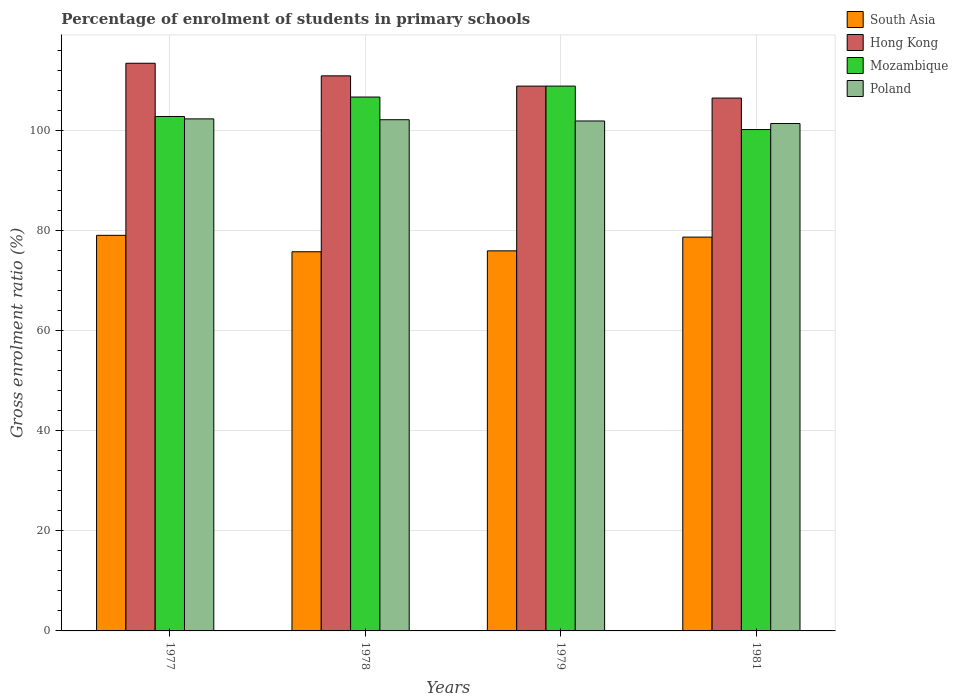Are the number of bars per tick equal to the number of legend labels?
Your answer should be very brief. Yes. How many bars are there on the 2nd tick from the left?
Keep it short and to the point. 4. How many bars are there on the 3rd tick from the right?
Provide a short and direct response. 4. What is the label of the 1st group of bars from the left?
Your answer should be very brief. 1977. What is the percentage of students enrolled in primary schools in Poland in 1979?
Your response must be concise. 101.88. Across all years, what is the maximum percentage of students enrolled in primary schools in Poland?
Keep it short and to the point. 102.3. Across all years, what is the minimum percentage of students enrolled in primary schools in South Asia?
Provide a short and direct response. 75.75. What is the total percentage of students enrolled in primary schools in Mozambique in the graph?
Ensure brevity in your answer.  418.45. What is the difference between the percentage of students enrolled in primary schools in South Asia in 1977 and that in 1979?
Provide a short and direct response. 3.1. What is the difference between the percentage of students enrolled in primary schools in Hong Kong in 1981 and the percentage of students enrolled in primary schools in Mozambique in 1978?
Keep it short and to the point. -0.21. What is the average percentage of students enrolled in primary schools in Mozambique per year?
Offer a terse response. 104.61. In the year 1979, what is the difference between the percentage of students enrolled in primary schools in Mozambique and percentage of students enrolled in primary schools in South Asia?
Your answer should be compact. 32.92. What is the ratio of the percentage of students enrolled in primary schools in Mozambique in 1978 to that in 1979?
Offer a very short reply. 0.98. Is the percentage of students enrolled in primary schools in Hong Kong in 1977 less than that in 1978?
Ensure brevity in your answer.  No. Is the difference between the percentage of students enrolled in primary schools in Mozambique in 1977 and 1981 greater than the difference between the percentage of students enrolled in primary schools in South Asia in 1977 and 1981?
Offer a terse response. Yes. What is the difference between the highest and the second highest percentage of students enrolled in primary schools in Mozambique?
Your answer should be compact. 2.19. What is the difference between the highest and the lowest percentage of students enrolled in primary schools in Poland?
Offer a very short reply. 0.93. In how many years, is the percentage of students enrolled in primary schools in Mozambique greater than the average percentage of students enrolled in primary schools in Mozambique taken over all years?
Your answer should be compact. 2. Is it the case that in every year, the sum of the percentage of students enrolled in primary schools in South Asia and percentage of students enrolled in primary schools in Mozambique is greater than the sum of percentage of students enrolled in primary schools in Hong Kong and percentage of students enrolled in primary schools in Poland?
Keep it short and to the point. Yes. What does the 1st bar from the left in 1977 represents?
Offer a terse response. South Asia. What does the 2nd bar from the right in 1977 represents?
Ensure brevity in your answer.  Mozambique. Is it the case that in every year, the sum of the percentage of students enrolled in primary schools in Hong Kong and percentage of students enrolled in primary schools in Mozambique is greater than the percentage of students enrolled in primary schools in Poland?
Make the answer very short. Yes. How many bars are there?
Keep it short and to the point. 16. How many years are there in the graph?
Provide a succinct answer. 4. Are the values on the major ticks of Y-axis written in scientific E-notation?
Keep it short and to the point. No. Where does the legend appear in the graph?
Your answer should be very brief. Top right. How many legend labels are there?
Offer a terse response. 4. How are the legend labels stacked?
Provide a succinct answer. Vertical. What is the title of the graph?
Give a very brief answer. Percentage of enrolment of students in primary schools. What is the label or title of the X-axis?
Keep it short and to the point. Years. What is the label or title of the Y-axis?
Your answer should be compact. Gross enrolment ratio (%). What is the Gross enrolment ratio (%) of South Asia in 1977?
Your response must be concise. 79.03. What is the Gross enrolment ratio (%) in Hong Kong in 1977?
Your answer should be very brief. 113.41. What is the Gross enrolment ratio (%) in Mozambique in 1977?
Your response must be concise. 102.78. What is the Gross enrolment ratio (%) of Poland in 1977?
Your response must be concise. 102.3. What is the Gross enrolment ratio (%) of South Asia in 1978?
Give a very brief answer. 75.75. What is the Gross enrolment ratio (%) of Hong Kong in 1978?
Your answer should be very brief. 110.89. What is the Gross enrolment ratio (%) in Mozambique in 1978?
Your response must be concise. 106.66. What is the Gross enrolment ratio (%) in Poland in 1978?
Provide a succinct answer. 102.13. What is the Gross enrolment ratio (%) of South Asia in 1979?
Offer a terse response. 75.93. What is the Gross enrolment ratio (%) in Hong Kong in 1979?
Your answer should be compact. 108.84. What is the Gross enrolment ratio (%) of Mozambique in 1979?
Make the answer very short. 108.85. What is the Gross enrolment ratio (%) in Poland in 1979?
Make the answer very short. 101.88. What is the Gross enrolment ratio (%) of South Asia in 1981?
Offer a terse response. 78.68. What is the Gross enrolment ratio (%) of Hong Kong in 1981?
Offer a terse response. 106.45. What is the Gross enrolment ratio (%) in Mozambique in 1981?
Offer a very short reply. 100.16. What is the Gross enrolment ratio (%) of Poland in 1981?
Provide a succinct answer. 101.37. Across all years, what is the maximum Gross enrolment ratio (%) of South Asia?
Give a very brief answer. 79.03. Across all years, what is the maximum Gross enrolment ratio (%) of Hong Kong?
Give a very brief answer. 113.41. Across all years, what is the maximum Gross enrolment ratio (%) of Mozambique?
Give a very brief answer. 108.85. Across all years, what is the maximum Gross enrolment ratio (%) in Poland?
Provide a short and direct response. 102.3. Across all years, what is the minimum Gross enrolment ratio (%) of South Asia?
Ensure brevity in your answer.  75.75. Across all years, what is the minimum Gross enrolment ratio (%) of Hong Kong?
Provide a succinct answer. 106.45. Across all years, what is the minimum Gross enrolment ratio (%) in Mozambique?
Make the answer very short. 100.16. Across all years, what is the minimum Gross enrolment ratio (%) of Poland?
Offer a very short reply. 101.37. What is the total Gross enrolment ratio (%) in South Asia in the graph?
Your answer should be compact. 309.39. What is the total Gross enrolment ratio (%) in Hong Kong in the graph?
Give a very brief answer. 439.6. What is the total Gross enrolment ratio (%) of Mozambique in the graph?
Your answer should be very brief. 418.45. What is the total Gross enrolment ratio (%) of Poland in the graph?
Keep it short and to the point. 407.67. What is the difference between the Gross enrolment ratio (%) of South Asia in 1977 and that in 1978?
Make the answer very short. 3.28. What is the difference between the Gross enrolment ratio (%) in Hong Kong in 1977 and that in 1978?
Ensure brevity in your answer.  2.52. What is the difference between the Gross enrolment ratio (%) in Mozambique in 1977 and that in 1978?
Your answer should be very brief. -3.89. What is the difference between the Gross enrolment ratio (%) of Poland in 1977 and that in 1978?
Your answer should be very brief. 0.17. What is the difference between the Gross enrolment ratio (%) of South Asia in 1977 and that in 1979?
Provide a succinct answer. 3.1. What is the difference between the Gross enrolment ratio (%) in Hong Kong in 1977 and that in 1979?
Offer a terse response. 4.57. What is the difference between the Gross enrolment ratio (%) in Mozambique in 1977 and that in 1979?
Give a very brief answer. -6.07. What is the difference between the Gross enrolment ratio (%) in Poland in 1977 and that in 1979?
Your response must be concise. 0.42. What is the difference between the Gross enrolment ratio (%) of South Asia in 1977 and that in 1981?
Give a very brief answer. 0.36. What is the difference between the Gross enrolment ratio (%) of Hong Kong in 1977 and that in 1981?
Provide a succinct answer. 6.96. What is the difference between the Gross enrolment ratio (%) in Mozambique in 1977 and that in 1981?
Ensure brevity in your answer.  2.61. What is the difference between the Gross enrolment ratio (%) of Poland in 1977 and that in 1981?
Offer a very short reply. 0.93. What is the difference between the Gross enrolment ratio (%) of South Asia in 1978 and that in 1979?
Your response must be concise. -0.18. What is the difference between the Gross enrolment ratio (%) in Hong Kong in 1978 and that in 1979?
Your answer should be compact. 2.05. What is the difference between the Gross enrolment ratio (%) of Mozambique in 1978 and that in 1979?
Give a very brief answer. -2.19. What is the difference between the Gross enrolment ratio (%) in Poland in 1978 and that in 1979?
Your answer should be compact. 0.25. What is the difference between the Gross enrolment ratio (%) in South Asia in 1978 and that in 1981?
Your answer should be compact. -2.93. What is the difference between the Gross enrolment ratio (%) of Hong Kong in 1978 and that in 1981?
Your response must be concise. 4.44. What is the difference between the Gross enrolment ratio (%) in Mozambique in 1978 and that in 1981?
Your answer should be compact. 6.5. What is the difference between the Gross enrolment ratio (%) of Poland in 1978 and that in 1981?
Offer a terse response. 0.76. What is the difference between the Gross enrolment ratio (%) in South Asia in 1979 and that in 1981?
Offer a terse response. -2.75. What is the difference between the Gross enrolment ratio (%) of Hong Kong in 1979 and that in 1981?
Your answer should be very brief. 2.39. What is the difference between the Gross enrolment ratio (%) of Mozambique in 1979 and that in 1981?
Provide a short and direct response. 8.68. What is the difference between the Gross enrolment ratio (%) in Poland in 1979 and that in 1981?
Provide a succinct answer. 0.51. What is the difference between the Gross enrolment ratio (%) of South Asia in 1977 and the Gross enrolment ratio (%) of Hong Kong in 1978?
Ensure brevity in your answer.  -31.86. What is the difference between the Gross enrolment ratio (%) in South Asia in 1977 and the Gross enrolment ratio (%) in Mozambique in 1978?
Provide a short and direct response. -27.63. What is the difference between the Gross enrolment ratio (%) of South Asia in 1977 and the Gross enrolment ratio (%) of Poland in 1978?
Your response must be concise. -23.09. What is the difference between the Gross enrolment ratio (%) of Hong Kong in 1977 and the Gross enrolment ratio (%) of Mozambique in 1978?
Your answer should be very brief. 6.75. What is the difference between the Gross enrolment ratio (%) in Hong Kong in 1977 and the Gross enrolment ratio (%) in Poland in 1978?
Offer a very short reply. 11.28. What is the difference between the Gross enrolment ratio (%) of Mozambique in 1977 and the Gross enrolment ratio (%) of Poland in 1978?
Your answer should be compact. 0.65. What is the difference between the Gross enrolment ratio (%) of South Asia in 1977 and the Gross enrolment ratio (%) of Hong Kong in 1979?
Give a very brief answer. -29.81. What is the difference between the Gross enrolment ratio (%) of South Asia in 1977 and the Gross enrolment ratio (%) of Mozambique in 1979?
Your answer should be very brief. -29.82. What is the difference between the Gross enrolment ratio (%) in South Asia in 1977 and the Gross enrolment ratio (%) in Poland in 1979?
Provide a succinct answer. -22.85. What is the difference between the Gross enrolment ratio (%) of Hong Kong in 1977 and the Gross enrolment ratio (%) of Mozambique in 1979?
Your response must be concise. 4.56. What is the difference between the Gross enrolment ratio (%) in Hong Kong in 1977 and the Gross enrolment ratio (%) in Poland in 1979?
Give a very brief answer. 11.53. What is the difference between the Gross enrolment ratio (%) in Mozambique in 1977 and the Gross enrolment ratio (%) in Poland in 1979?
Your answer should be very brief. 0.9. What is the difference between the Gross enrolment ratio (%) of South Asia in 1977 and the Gross enrolment ratio (%) of Hong Kong in 1981?
Keep it short and to the point. -27.42. What is the difference between the Gross enrolment ratio (%) in South Asia in 1977 and the Gross enrolment ratio (%) in Mozambique in 1981?
Give a very brief answer. -21.13. What is the difference between the Gross enrolment ratio (%) in South Asia in 1977 and the Gross enrolment ratio (%) in Poland in 1981?
Give a very brief answer. -22.34. What is the difference between the Gross enrolment ratio (%) in Hong Kong in 1977 and the Gross enrolment ratio (%) in Mozambique in 1981?
Ensure brevity in your answer.  13.24. What is the difference between the Gross enrolment ratio (%) in Hong Kong in 1977 and the Gross enrolment ratio (%) in Poland in 1981?
Your answer should be compact. 12.04. What is the difference between the Gross enrolment ratio (%) in Mozambique in 1977 and the Gross enrolment ratio (%) in Poland in 1981?
Give a very brief answer. 1.41. What is the difference between the Gross enrolment ratio (%) of South Asia in 1978 and the Gross enrolment ratio (%) of Hong Kong in 1979?
Ensure brevity in your answer.  -33.09. What is the difference between the Gross enrolment ratio (%) in South Asia in 1978 and the Gross enrolment ratio (%) in Mozambique in 1979?
Offer a very short reply. -33.1. What is the difference between the Gross enrolment ratio (%) in South Asia in 1978 and the Gross enrolment ratio (%) in Poland in 1979?
Offer a terse response. -26.13. What is the difference between the Gross enrolment ratio (%) of Hong Kong in 1978 and the Gross enrolment ratio (%) of Mozambique in 1979?
Your answer should be very brief. 2.04. What is the difference between the Gross enrolment ratio (%) in Hong Kong in 1978 and the Gross enrolment ratio (%) in Poland in 1979?
Provide a short and direct response. 9.01. What is the difference between the Gross enrolment ratio (%) in Mozambique in 1978 and the Gross enrolment ratio (%) in Poland in 1979?
Your answer should be very brief. 4.78. What is the difference between the Gross enrolment ratio (%) of South Asia in 1978 and the Gross enrolment ratio (%) of Hong Kong in 1981?
Ensure brevity in your answer.  -30.7. What is the difference between the Gross enrolment ratio (%) in South Asia in 1978 and the Gross enrolment ratio (%) in Mozambique in 1981?
Provide a succinct answer. -24.42. What is the difference between the Gross enrolment ratio (%) in South Asia in 1978 and the Gross enrolment ratio (%) in Poland in 1981?
Ensure brevity in your answer.  -25.62. What is the difference between the Gross enrolment ratio (%) of Hong Kong in 1978 and the Gross enrolment ratio (%) of Mozambique in 1981?
Offer a very short reply. 10.73. What is the difference between the Gross enrolment ratio (%) in Hong Kong in 1978 and the Gross enrolment ratio (%) in Poland in 1981?
Offer a terse response. 9.52. What is the difference between the Gross enrolment ratio (%) of Mozambique in 1978 and the Gross enrolment ratio (%) of Poland in 1981?
Your answer should be very brief. 5.29. What is the difference between the Gross enrolment ratio (%) of South Asia in 1979 and the Gross enrolment ratio (%) of Hong Kong in 1981?
Offer a terse response. -30.52. What is the difference between the Gross enrolment ratio (%) in South Asia in 1979 and the Gross enrolment ratio (%) in Mozambique in 1981?
Keep it short and to the point. -24.24. What is the difference between the Gross enrolment ratio (%) in South Asia in 1979 and the Gross enrolment ratio (%) in Poland in 1981?
Provide a succinct answer. -25.44. What is the difference between the Gross enrolment ratio (%) in Hong Kong in 1979 and the Gross enrolment ratio (%) in Mozambique in 1981?
Give a very brief answer. 8.68. What is the difference between the Gross enrolment ratio (%) in Hong Kong in 1979 and the Gross enrolment ratio (%) in Poland in 1981?
Offer a very short reply. 7.47. What is the difference between the Gross enrolment ratio (%) of Mozambique in 1979 and the Gross enrolment ratio (%) of Poland in 1981?
Provide a succinct answer. 7.48. What is the average Gross enrolment ratio (%) of South Asia per year?
Make the answer very short. 77.35. What is the average Gross enrolment ratio (%) in Hong Kong per year?
Make the answer very short. 109.9. What is the average Gross enrolment ratio (%) in Mozambique per year?
Make the answer very short. 104.61. What is the average Gross enrolment ratio (%) in Poland per year?
Make the answer very short. 101.92. In the year 1977, what is the difference between the Gross enrolment ratio (%) of South Asia and Gross enrolment ratio (%) of Hong Kong?
Keep it short and to the point. -34.38. In the year 1977, what is the difference between the Gross enrolment ratio (%) in South Asia and Gross enrolment ratio (%) in Mozambique?
Ensure brevity in your answer.  -23.74. In the year 1977, what is the difference between the Gross enrolment ratio (%) in South Asia and Gross enrolment ratio (%) in Poland?
Your answer should be compact. -23.26. In the year 1977, what is the difference between the Gross enrolment ratio (%) in Hong Kong and Gross enrolment ratio (%) in Mozambique?
Your answer should be compact. 10.63. In the year 1977, what is the difference between the Gross enrolment ratio (%) of Hong Kong and Gross enrolment ratio (%) of Poland?
Make the answer very short. 11.11. In the year 1977, what is the difference between the Gross enrolment ratio (%) in Mozambique and Gross enrolment ratio (%) in Poland?
Your answer should be very brief. 0.48. In the year 1978, what is the difference between the Gross enrolment ratio (%) of South Asia and Gross enrolment ratio (%) of Hong Kong?
Ensure brevity in your answer.  -35.14. In the year 1978, what is the difference between the Gross enrolment ratio (%) of South Asia and Gross enrolment ratio (%) of Mozambique?
Your answer should be compact. -30.91. In the year 1978, what is the difference between the Gross enrolment ratio (%) in South Asia and Gross enrolment ratio (%) in Poland?
Your answer should be compact. -26.38. In the year 1978, what is the difference between the Gross enrolment ratio (%) of Hong Kong and Gross enrolment ratio (%) of Mozambique?
Your answer should be very brief. 4.23. In the year 1978, what is the difference between the Gross enrolment ratio (%) in Hong Kong and Gross enrolment ratio (%) in Poland?
Make the answer very short. 8.76. In the year 1978, what is the difference between the Gross enrolment ratio (%) in Mozambique and Gross enrolment ratio (%) in Poland?
Give a very brief answer. 4.53. In the year 1979, what is the difference between the Gross enrolment ratio (%) of South Asia and Gross enrolment ratio (%) of Hong Kong?
Your response must be concise. -32.91. In the year 1979, what is the difference between the Gross enrolment ratio (%) of South Asia and Gross enrolment ratio (%) of Mozambique?
Give a very brief answer. -32.92. In the year 1979, what is the difference between the Gross enrolment ratio (%) of South Asia and Gross enrolment ratio (%) of Poland?
Ensure brevity in your answer.  -25.95. In the year 1979, what is the difference between the Gross enrolment ratio (%) of Hong Kong and Gross enrolment ratio (%) of Mozambique?
Provide a short and direct response. -0. In the year 1979, what is the difference between the Gross enrolment ratio (%) in Hong Kong and Gross enrolment ratio (%) in Poland?
Keep it short and to the point. 6.97. In the year 1979, what is the difference between the Gross enrolment ratio (%) of Mozambique and Gross enrolment ratio (%) of Poland?
Your answer should be very brief. 6.97. In the year 1981, what is the difference between the Gross enrolment ratio (%) in South Asia and Gross enrolment ratio (%) in Hong Kong?
Your answer should be very brief. -27.78. In the year 1981, what is the difference between the Gross enrolment ratio (%) in South Asia and Gross enrolment ratio (%) in Mozambique?
Provide a short and direct response. -21.49. In the year 1981, what is the difference between the Gross enrolment ratio (%) in South Asia and Gross enrolment ratio (%) in Poland?
Give a very brief answer. -22.7. In the year 1981, what is the difference between the Gross enrolment ratio (%) in Hong Kong and Gross enrolment ratio (%) in Mozambique?
Give a very brief answer. 6.29. In the year 1981, what is the difference between the Gross enrolment ratio (%) in Hong Kong and Gross enrolment ratio (%) in Poland?
Your answer should be very brief. 5.08. In the year 1981, what is the difference between the Gross enrolment ratio (%) in Mozambique and Gross enrolment ratio (%) in Poland?
Ensure brevity in your answer.  -1.21. What is the ratio of the Gross enrolment ratio (%) in South Asia in 1977 to that in 1978?
Keep it short and to the point. 1.04. What is the ratio of the Gross enrolment ratio (%) in Hong Kong in 1977 to that in 1978?
Provide a short and direct response. 1.02. What is the ratio of the Gross enrolment ratio (%) of Mozambique in 1977 to that in 1978?
Make the answer very short. 0.96. What is the ratio of the Gross enrolment ratio (%) in Poland in 1977 to that in 1978?
Your response must be concise. 1. What is the ratio of the Gross enrolment ratio (%) in South Asia in 1977 to that in 1979?
Ensure brevity in your answer.  1.04. What is the ratio of the Gross enrolment ratio (%) of Hong Kong in 1977 to that in 1979?
Offer a terse response. 1.04. What is the ratio of the Gross enrolment ratio (%) of Mozambique in 1977 to that in 1979?
Offer a terse response. 0.94. What is the ratio of the Gross enrolment ratio (%) in Poland in 1977 to that in 1979?
Offer a terse response. 1. What is the ratio of the Gross enrolment ratio (%) of Hong Kong in 1977 to that in 1981?
Your response must be concise. 1.07. What is the ratio of the Gross enrolment ratio (%) in Mozambique in 1977 to that in 1981?
Ensure brevity in your answer.  1.03. What is the ratio of the Gross enrolment ratio (%) of Poland in 1977 to that in 1981?
Give a very brief answer. 1.01. What is the ratio of the Gross enrolment ratio (%) of South Asia in 1978 to that in 1979?
Your answer should be compact. 1. What is the ratio of the Gross enrolment ratio (%) in Hong Kong in 1978 to that in 1979?
Provide a succinct answer. 1.02. What is the ratio of the Gross enrolment ratio (%) of Mozambique in 1978 to that in 1979?
Provide a succinct answer. 0.98. What is the ratio of the Gross enrolment ratio (%) in Poland in 1978 to that in 1979?
Ensure brevity in your answer.  1. What is the ratio of the Gross enrolment ratio (%) of South Asia in 1978 to that in 1981?
Provide a short and direct response. 0.96. What is the ratio of the Gross enrolment ratio (%) in Hong Kong in 1978 to that in 1981?
Provide a short and direct response. 1.04. What is the ratio of the Gross enrolment ratio (%) in Mozambique in 1978 to that in 1981?
Keep it short and to the point. 1.06. What is the ratio of the Gross enrolment ratio (%) of Poland in 1978 to that in 1981?
Your response must be concise. 1.01. What is the ratio of the Gross enrolment ratio (%) of South Asia in 1979 to that in 1981?
Offer a terse response. 0.97. What is the ratio of the Gross enrolment ratio (%) of Hong Kong in 1979 to that in 1981?
Give a very brief answer. 1.02. What is the ratio of the Gross enrolment ratio (%) of Mozambique in 1979 to that in 1981?
Offer a terse response. 1.09. What is the ratio of the Gross enrolment ratio (%) in Poland in 1979 to that in 1981?
Offer a terse response. 1. What is the difference between the highest and the second highest Gross enrolment ratio (%) in South Asia?
Provide a short and direct response. 0.36. What is the difference between the highest and the second highest Gross enrolment ratio (%) of Hong Kong?
Your answer should be very brief. 2.52. What is the difference between the highest and the second highest Gross enrolment ratio (%) of Mozambique?
Keep it short and to the point. 2.19. What is the difference between the highest and the second highest Gross enrolment ratio (%) in Poland?
Your answer should be compact. 0.17. What is the difference between the highest and the lowest Gross enrolment ratio (%) of South Asia?
Ensure brevity in your answer.  3.28. What is the difference between the highest and the lowest Gross enrolment ratio (%) in Hong Kong?
Ensure brevity in your answer.  6.96. What is the difference between the highest and the lowest Gross enrolment ratio (%) of Mozambique?
Provide a succinct answer. 8.68. What is the difference between the highest and the lowest Gross enrolment ratio (%) of Poland?
Your answer should be compact. 0.93. 